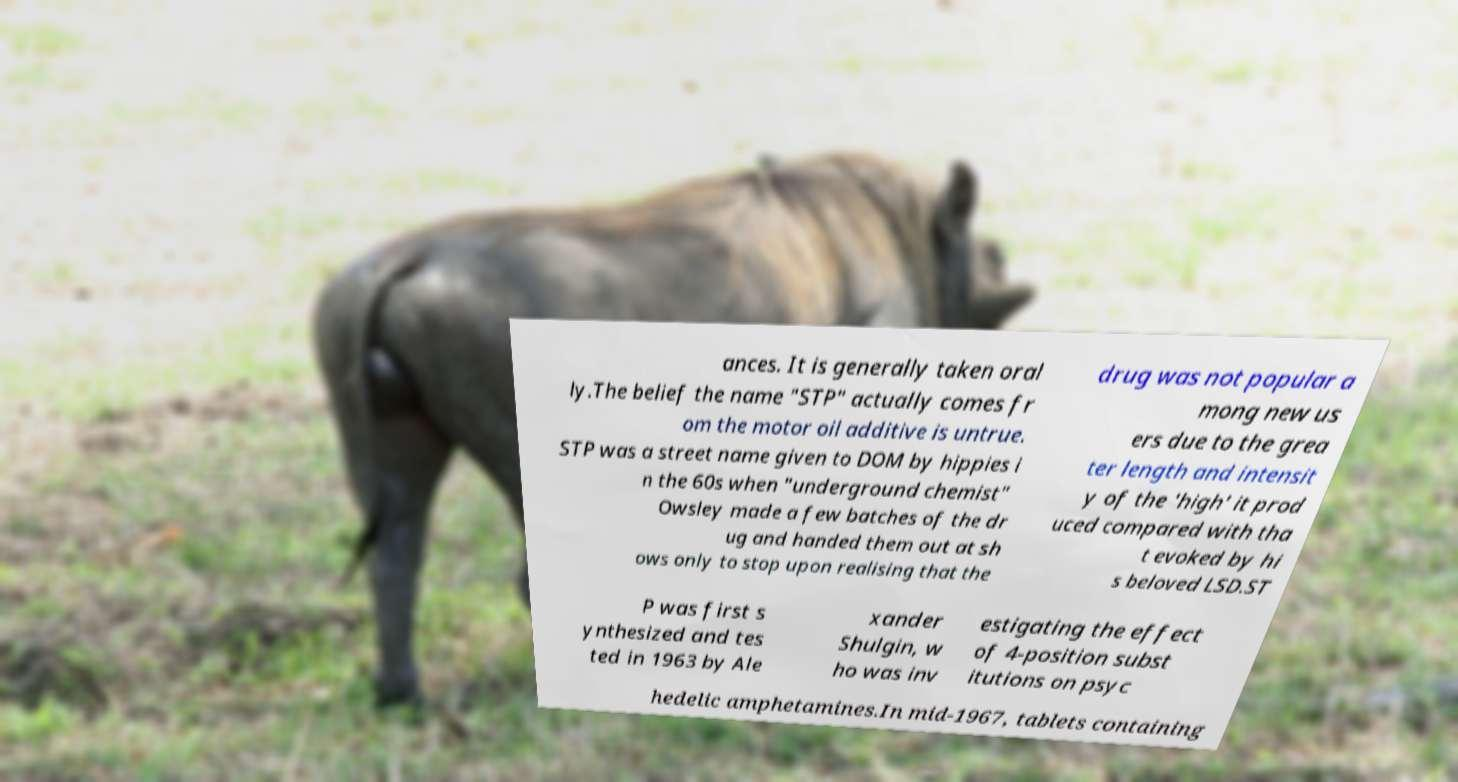Please identify and transcribe the text found in this image. ances. It is generally taken oral ly.The belief the name "STP" actually comes fr om the motor oil additive is untrue. STP was a street name given to DOM by hippies i n the 60s when "underground chemist" Owsley made a few batches of the dr ug and handed them out at sh ows only to stop upon realising that the drug was not popular a mong new us ers due to the grea ter length and intensit y of the 'high' it prod uced compared with tha t evoked by hi s beloved LSD.ST P was first s ynthesized and tes ted in 1963 by Ale xander Shulgin, w ho was inv estigating the effect of 4-position subst itutions on psyc hedelic amphetamines.In mid-1967, tablets containing 